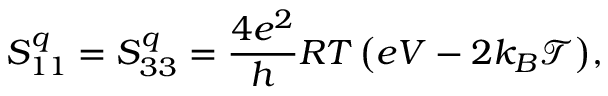Convert formula to latex. <formula><loc_0><loc_0><loc_500><loc_500>{ S _ { 1 1 } ^ { q } = S _ { 3 3 } ^ { q } = \frac { 4 e ^ { 2 } } { h } R T \left ( e V - 2 k _ { B } \mathcal { T } \right ) } ,</formula> 